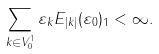Convert formula to latex. <formula><loc_0><loc_0><loc_500><loc_500>\sum _ { k \in V _ { 0 } ^ { 1 } } \| \varepsilon _ { k } E _ { | k | } ( \varepsilon _ { 0 } ) \| _ { 1 } < \infty .</formula> 